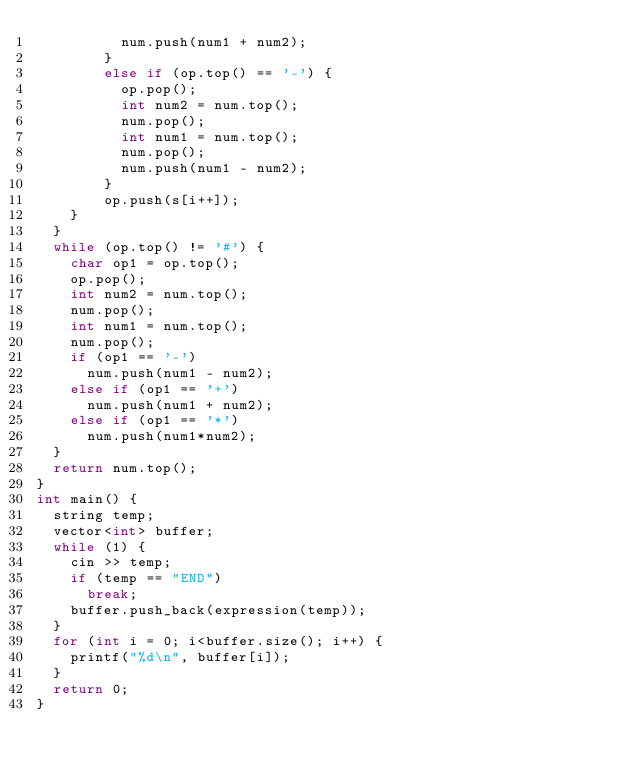<code> <loc_0><loc_0><loc_500><loc_500><_C++_>					num.push(num1 + num2);
				}
				else if (op.top() == '-') {
					op.pop();
					int num2 = num.top();
					num.pop();
					int num1 = num.top();
					num.pop();
					num.push(num1 - num2);
				}
				op.push(s[i++]);
		}
	}
	while (op.top() != '#') {
		char op1 = op.top();
		op.pop();
		int num2 = num.top();
		num.pop();
		int num1 = num.top();
		num.pop();
		if (op1 == '-')
			num.push(num1 - num2);
		else if (op1 == '+')
			num.push(num1 + num2);
		else if (op1 == '*')
			num.push(num1*num2);
	}
	return num.top();
}
int main() {
	string temp;
	vector<int> buffer;
	while (1) {
		cin >> temp;
		if (temp == "END")
			break;
		buffer.push_back(expression(temp));
	}
	for (int i = 0; i<buffer.size(); i++) {
		printf("%d\n", buffer[i]);
	}
	return 0;
}</code> 